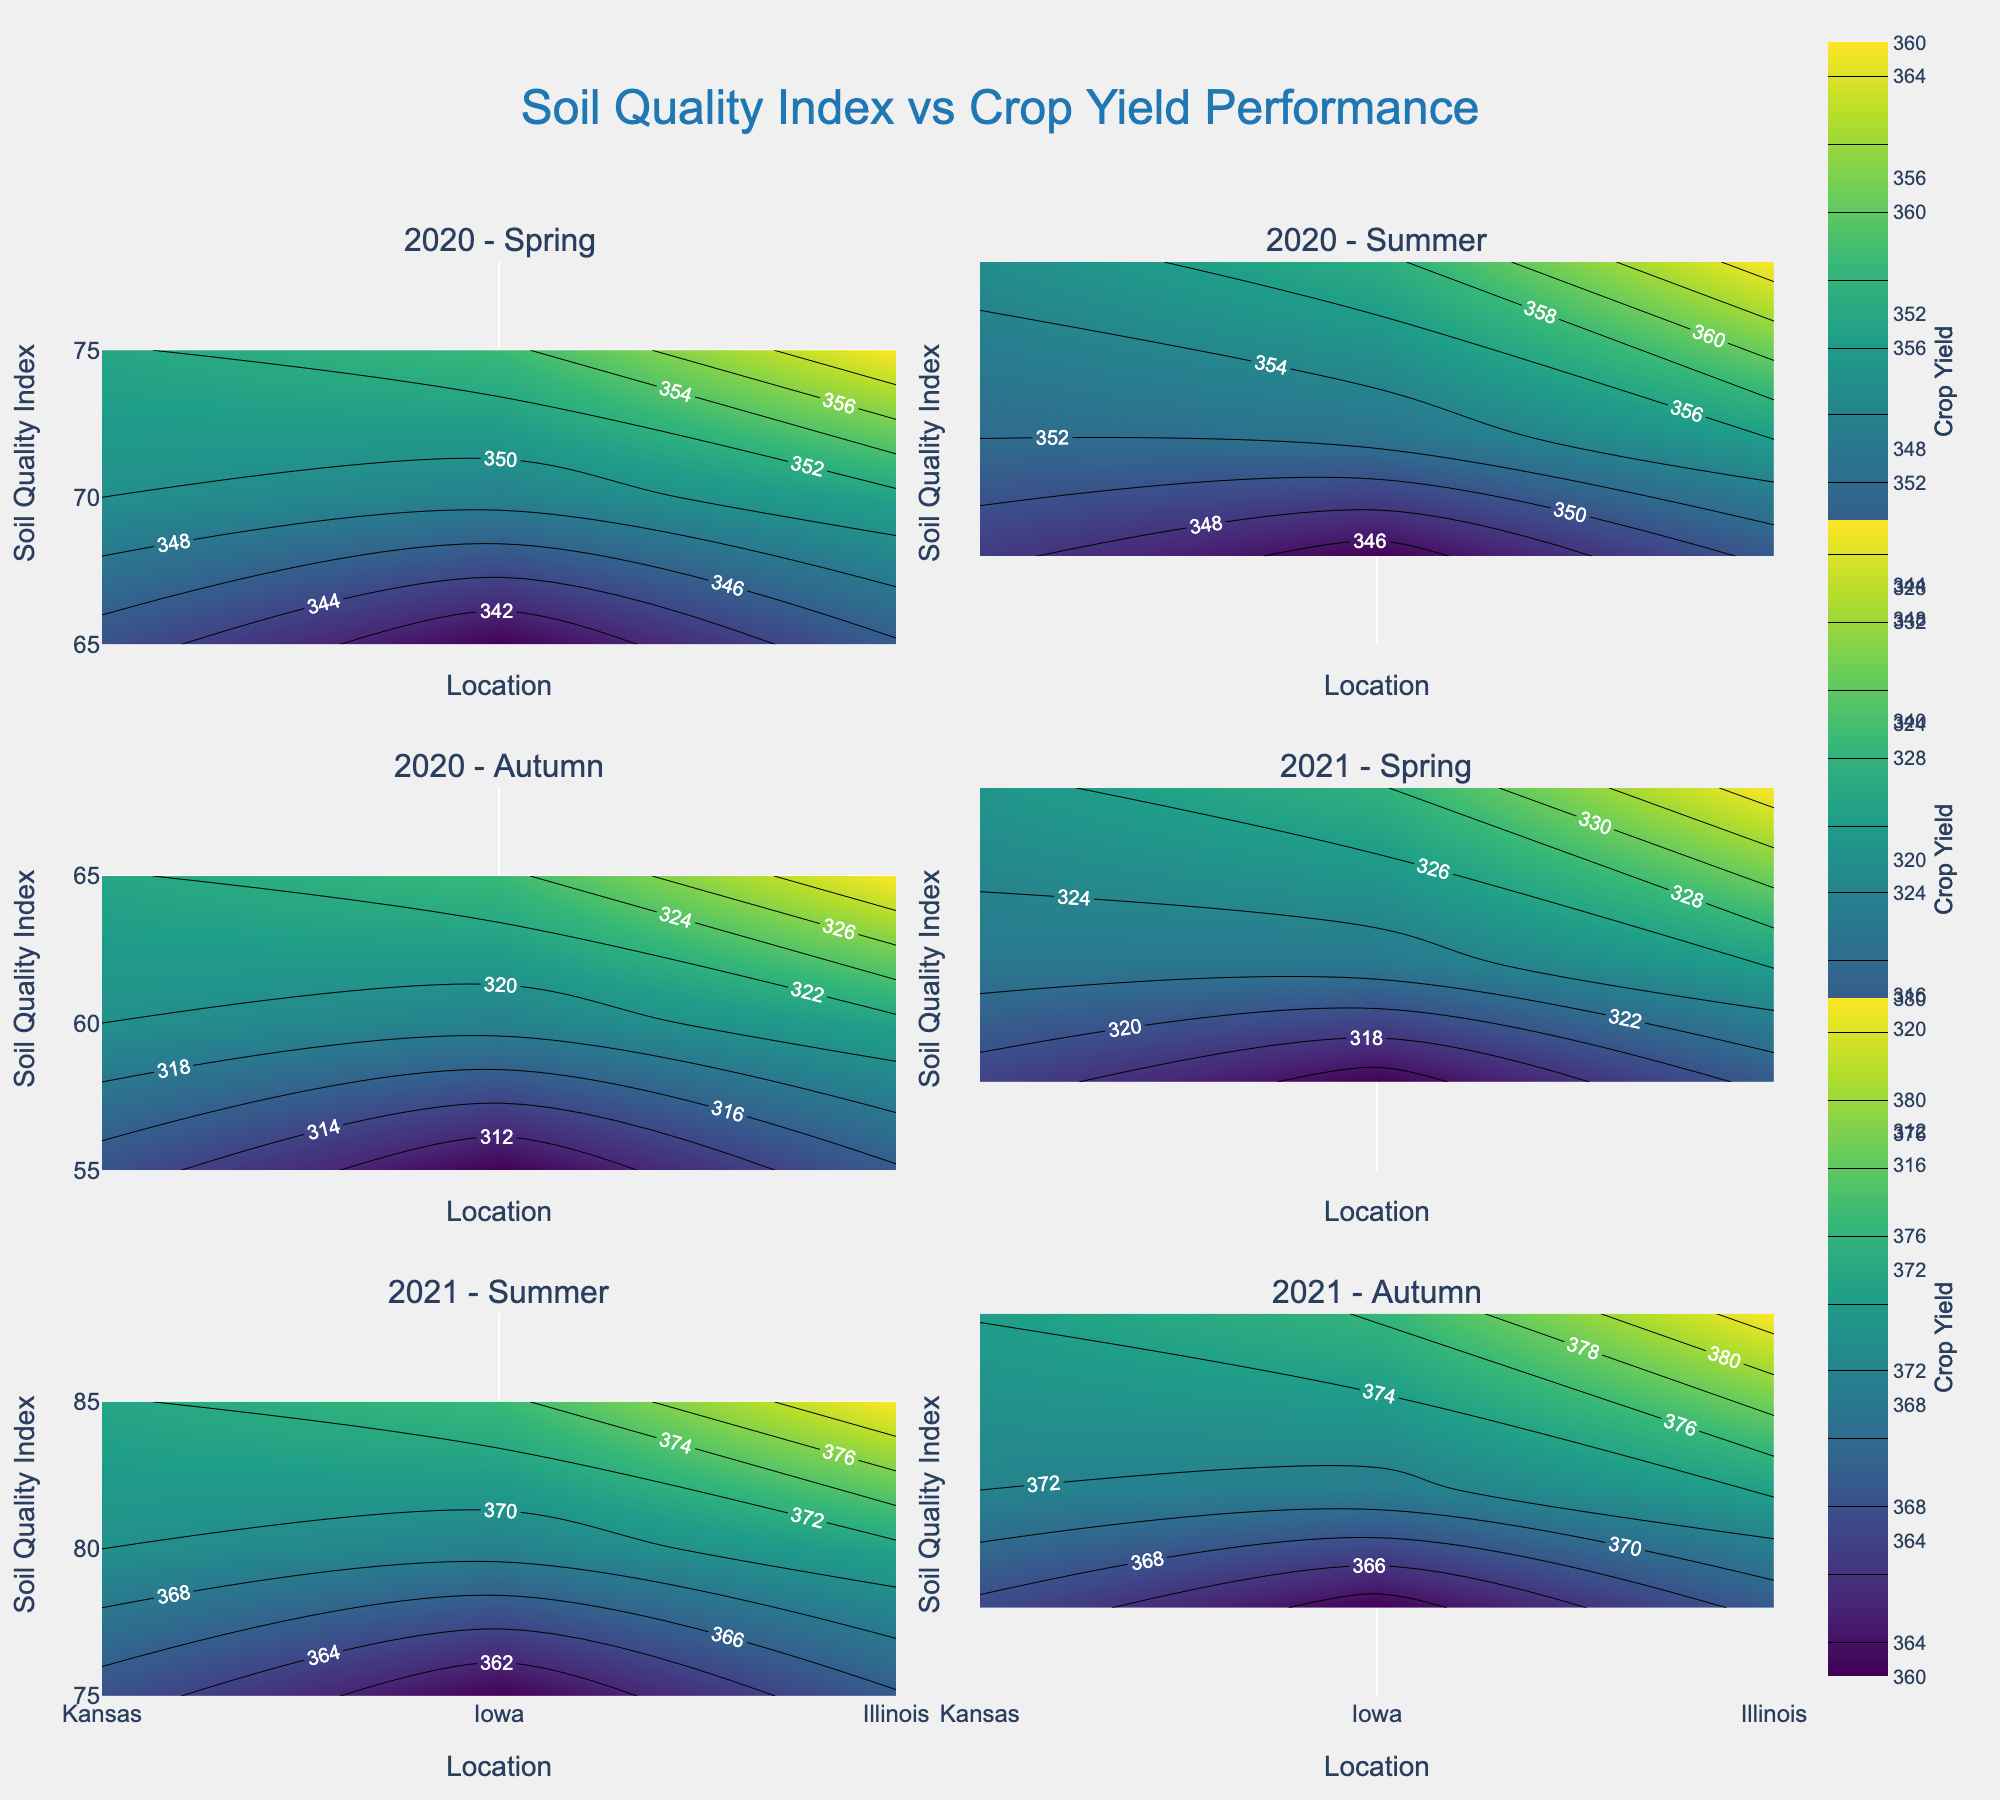What's the title of the plot? The title is usually located at the top of the figure and is often in a larger font size to grab attention. In this plot, the title is "Soil Quality Index vs Crop Yield Performance".
Answer: Soil Quality Index vs Crop Yield Performance How many subplots are there in the figure? Each unique combination of year and season creates a subplot, and there are 2 years (2020, 2021) and 3 seasons (Spring, Summer, Autumn).
Answer: 6 Which location has the highest crop yield in Autumn 2020? Look for the contour plot corresponding to Autumn 2020 and identify the location with the highest crop yield value. Illinois shows a crop yield of 380.
Answer: Illinois Which year had the highest soil quality index in Autumn for Kansas? Compare the soil quality index for Kansas in the Autumn of both 2020 and 2021. The soil quality index is higher in 2021 (82) compared to 2020 (80).
Answer: 2021 How does the crop yield in Kansas during Spring 2021 compare to Spring 2020? For Kansas in Spring 2021 and 2020, observe the crop yield values. In Spring 2021, the crop yield is 352, slightly higher than 350 in Spring 2020.
Answer: Slightly higher in 2021 What is the general trend of soil quality and crop yield from Spring to Autumn in 2020? By examining each season's subplot for 2020, observe how soil quality and crop yield values change from Spring to Autumn. The trend shows an increase in both soil quality (from 70 to 85) and crop yield (from 350 to 380).
Answer: Both increase Which season showed the lowest crop yield in Iowa for 2021? Look at the subplots for Iowa in each season of 2021 and identify the minimum crop yield value; Summer has the lowest at 315.
Answer: Summer What color represents the highest crop yield on the contour plots? Look at the legend and color scale on the figure. The highest crop yield is represented by the darkest color according to the Viridis color scale used in the plot.
Answer: Dark purple Compare soil quality indexes in Spring between Illinois and Iowa in 2021. On the subplot for Spring 2021, note the soil quality index for Illinois (78) and Iowa (68). Illinois has a higher soil quality index.
Answer: Illinois is higher Does the soil quality index show significant variation across locations within the same season and year? Inspect the soil quality index values (y-axis) for each subplot within a specific season and year. Slight differences are present, but the ranges are relatively small indicating limited variation.
Answer: Limited variation 